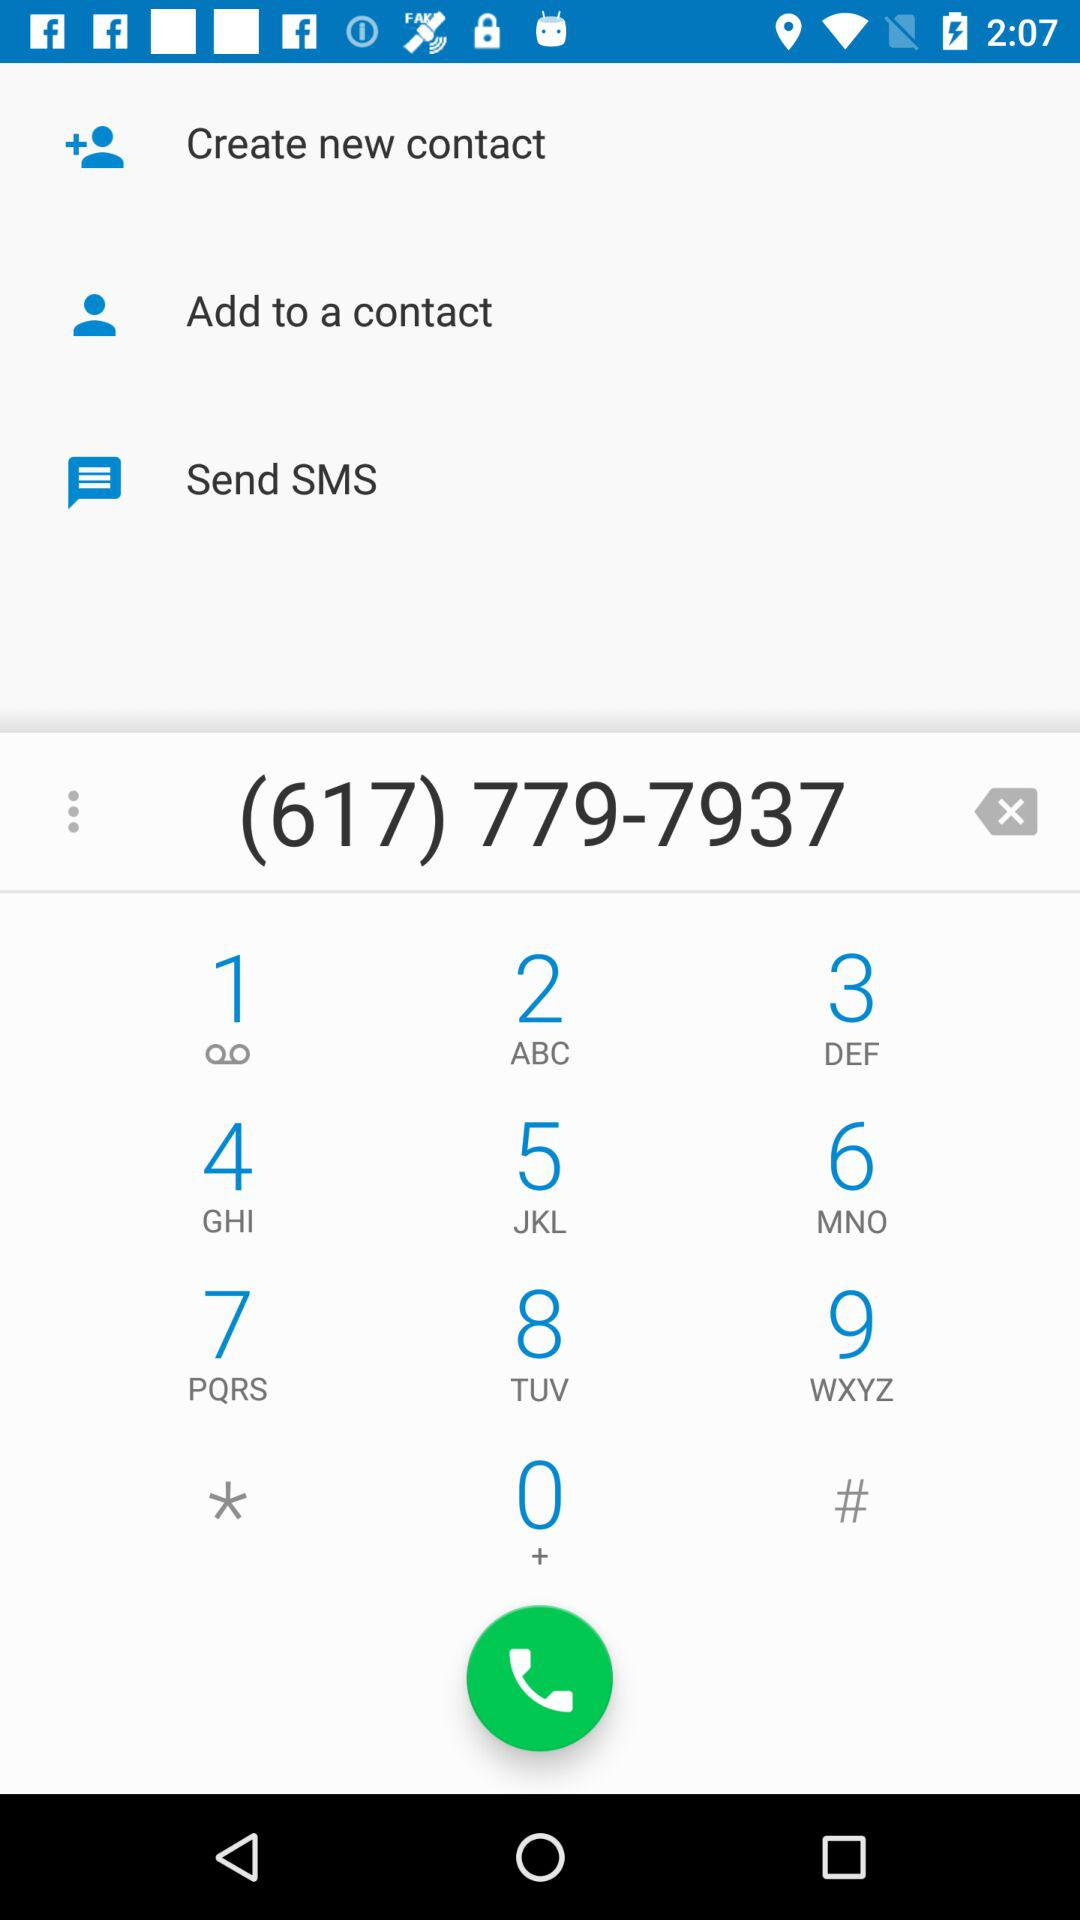What's the area code? The area code is 617. 